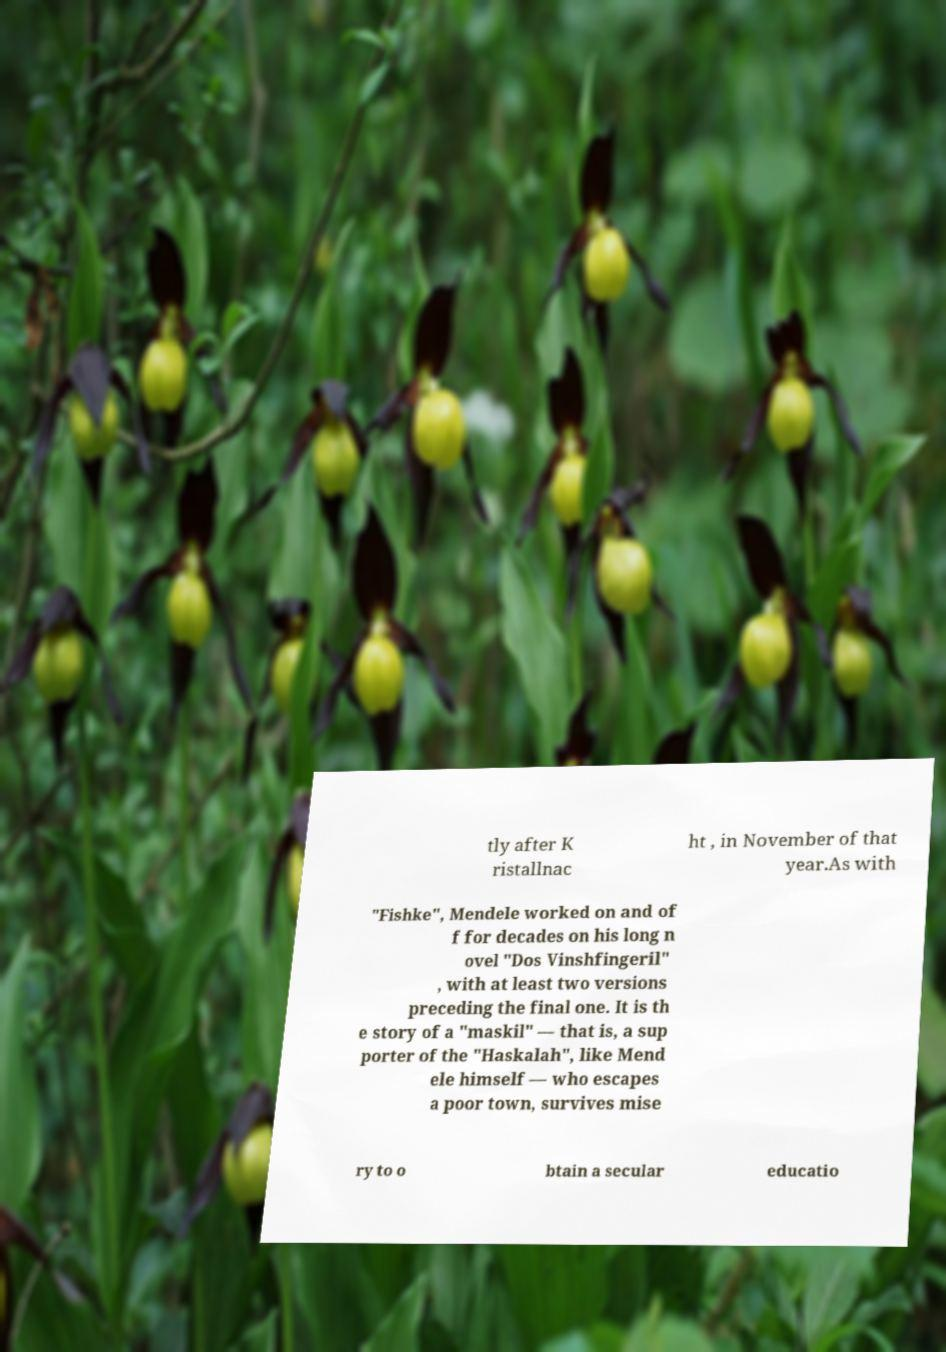There's text embedded in this image that I need extracted. Can you transcribe it verbatim? tly after K ristallnac ht , in November of that year.As with "Fishke", Mendele worked on and of f for decades on his long n ovel "Dos Vinshfingeril" , with at least two versions preceding the final one. It is th e story of a "maskil" — that is, a sup porter of the "Haskalah", like Mend ele himself — who escapes a poor town, survives mise ry to o btain a secular educatio 